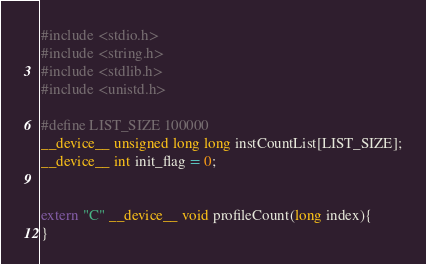<code> <loc_0><loc_0><loc_500><loc_500><_Cuda_>#include <stdio.h>
#include <string.h>
#include <stdlib.h>
#include <unistd.h>

#define LIST_SIZE 100000
__device__ unsigned long long instCountList[LIST_SIZE];
__device__ int init_flag = 0;


extern "C" __device__ void profileCount(long index){
}
</code> 